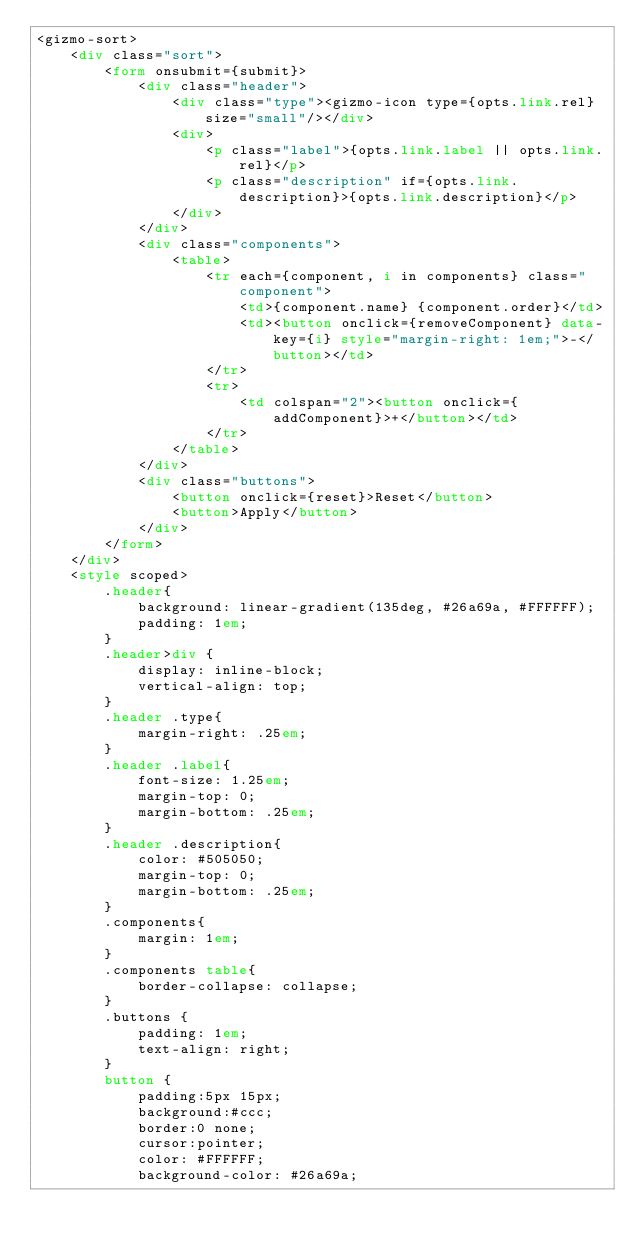Convert code to text. <code><loc_0><loc_0><loc_500><loc_500><_HTML_><gizmo-sort>
    <div class="sort">
        <form onsubmit={submit}>
            <div class="header">
                <div class="type"><gizmo-icon type={opts.link.rel} size="small"/></div>
                <div>
                    <p class="label">{opts.link.label || opts.link.rel}</p>
                    <p class="description" if={opts.link.description}>{opts.link.description}</p>
                </div>
            </div>
            <div class="components">
                <table>
                    <tr each={component, i in components} class="component">
                        <td>{component.name} {component.order}</td>
                        <td><button onclick={removeComponent} data-key={i} style="margin-right: 1em;">-</button></td>
                    </tr>
                    <tr>
                        <td colspan="2"><button onclick={addComponent}>+</button></td>
                    </tr>
                </table>
            </div>
            <div class="buttons">
                <button onclick={reset}>Reset</button>
                <button>Apply</button>
            </div>
        </form>
    </div>
    <style scoped>
        .header{
            background: linear-gradient(135deg, #26a69a, #FFFFFF); 
            padding: 1em;
        }
        .header>div {
            display: inline-block;
            vertical-align: top;
        }
        .header .type{
            margin-right: .25em;
        }
        .header .label{
            font-size: 1.25em;
            margin-top: 0;
            margin-bottom: .25em;
        }
        .header .description{
            color: #505050;
            margin-top: 0;
            margin-bottom: .25em;
        }
        .components{
            margin: 1em;
        }
        .components table{
            border-collapse: collapse;
        }
        .buttons {
            padding: 1em;
            text-align: right;
        }
        button {
            padding:5px 15px; 
            background:#ccc; 
            border:0 none;
            cursor:pointer;
            color: #FFFFFF;
            background-color: #26a69a;</code> 